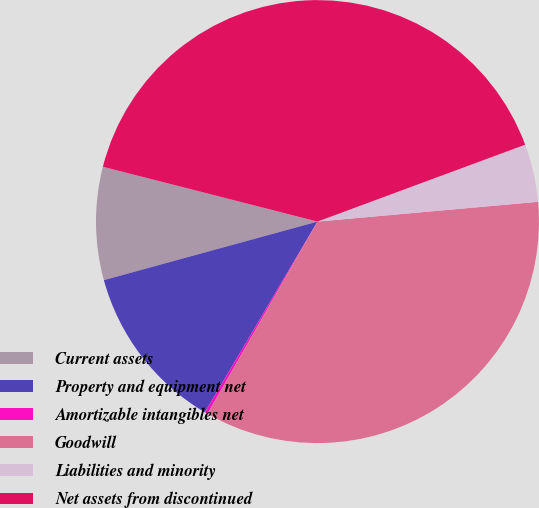Convert chart to OTSL. <chart><loc_0><loc_0><loc_500><loc_500><pie_chart><fcel>Current assets<fcel>Property and equipment net<fcel>Amortizable intangibles net<fcel>Goodwill<fcel>Liabilities and minority<fcel>Net assets from discontinued<nl><fcel>8.24%<fcel>12.26%<fcel>0.21%<fcel>34.7%<fcel>4.22%<fcel>40.38%<nl></chart> 